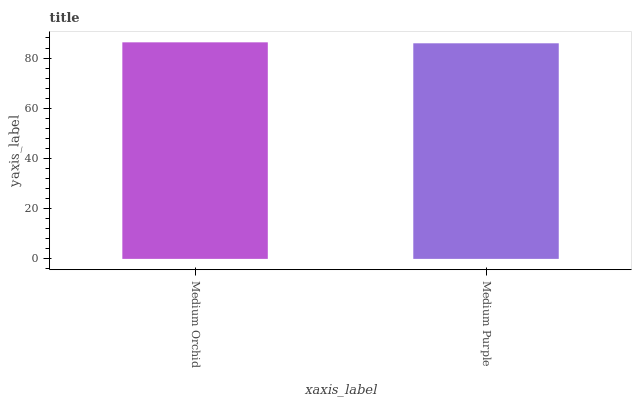Is Medium Purple the minimum?
Answer yes or no. Yes. Is Medium Orchid the maximum?
Answer yes or no. Yes. Is Medium Purple the maximum?
Answer yes or no. No. Is Medium Orchid greater than Medium Purple?
Answer yes or no. Yes. Is Medium Purple less than Medium Orchid?
Answer yes or no. Yes. Is Medium Purple greater than Medium Orchid?
Answer yes or no. No. Is Medium Orchid less than Medium Purple?
Answer yes or no. No. Is Medium Orchid the high median?
Answer yes or no. Yes. Is Medium Purple the low median?
Answer yes or no. Yes. Is Medium Purple the high median?
Answer yes or no. No. Is Medium Orchid the low median?
Answer yes or no. No. 